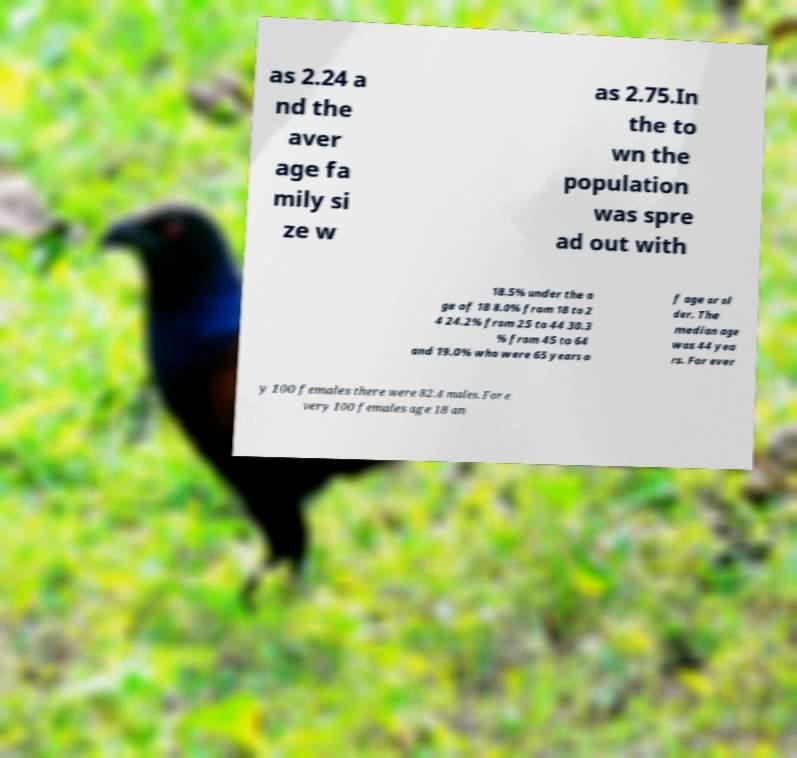Could you extract and type out the text from this image? as 2.24 a nd the aver age fa mily si ze w as 2.75.In the to wn the population was spre ad out with 18.5% under the a ge of 18 8.0% from 18 to 2 4 24.2% from 25 to 44 30.3 % from 45 to 64 and 19.0% who were 65 years o f age or ol der. The median age was 44 yea rs. For ever y 100 females there were 82.4 males. For e very 100 females age 18 an 